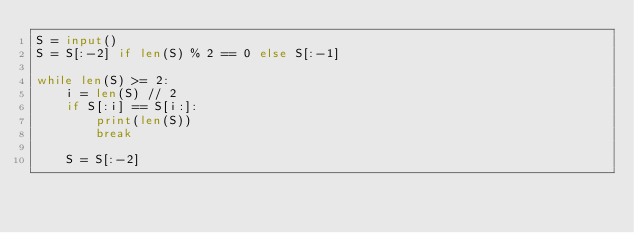<code> <loc_0><loc_0><loc_500><loc_500><_Python_>S = input()
S = S[:-2] if len(S) % 2 == 0 else S[:-1]

while len(S) >= 2:
    i = len(S) // 2
    if S[:i] == S[i:]:
        print(len(S))
        break

    S = S[:-2]
</code> 